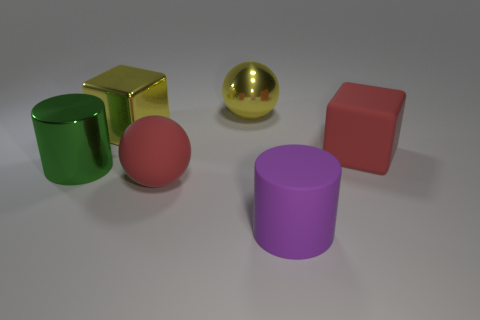Is the number of yellow metallic blocks that are to the left of the large metal block less than the number of big shiny blocks that are in front of the purple rubber object?
Offer a terse response. No. What number of objects are big red things that are left of the rubber cylinder or rubber spheres?
Your answer should be compact. 1. There is a purple object; is it the same size as the yellow metallic object that is left of the red matte sphere?
Make the answer very short. Yes. What size is the matte object that is the same shape as the big green metallic thing?
Your answer should be compact. Large. There is a big yellow thing left of the red thing that is in front of the large rubber block; how many yellow metallic objects are to the left of it?
Offer a very short reply. 0. How many cylinders are either big brown shiny things or large red objects?
Keep it short and to the point. 0. There is a metal object that is to the right of the block that is to the left of the thing to the right of the large matte cylinder; what is its color?
Your answer should be very brief. Yellow. How many other things are there of the same size as the green shiny cylinder?
Give a very brief answer. 5. Are there any other things that are the same shape as the big purple thing?
Give a very brief answer. Yes. What is the color of the other object that is the same shape as the large green object?
Give a very brief answer. Purple. 